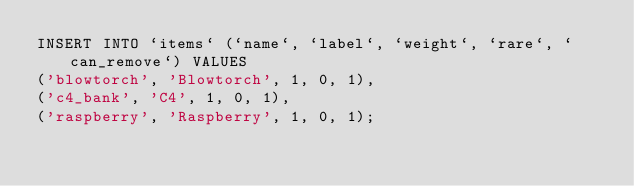<code> <loc_0><loc_0><loc_500><loc_500><_SQL_>INSERT INTO `items` (`name`, `label`, `weight`, `rare`, `can_remove`) VALUES
('blowtorch', 'Blowtorch', 1, 0, 1),
('c4_bank', 'C4', 1, 0, 1),
('raspberry', 'Raspberry', 1, 0, 1);
</code> 